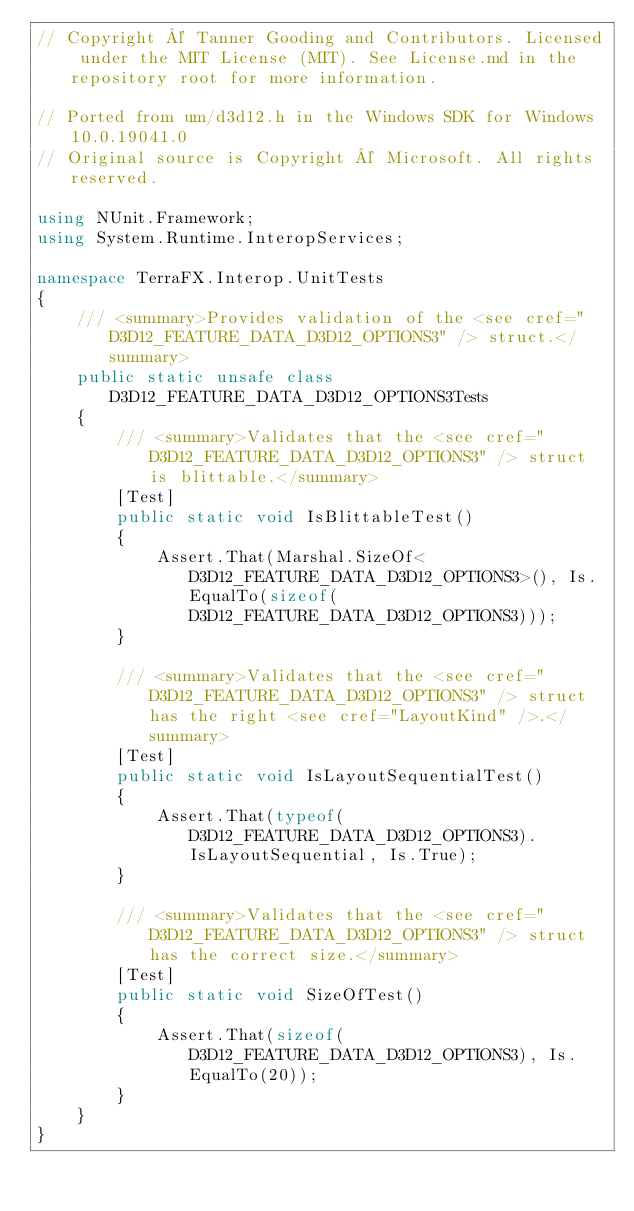<code> <loc_0><loc_0><loc_500><loc_500><_C#_>// Copyright © Tanner Gooding and Contributors. Licensed under the MIT License (MIT). See License.md in the repository root for more information.

// Ported from um/d3d12.h in the Windows SDK for Windows 10.0.19041.0
// Original source is Copyright © Microsoft. All rights reserved.

using NUnit.Framework;
using System.Runtime.InteropServices;

namespace TerraFX.Interop.UnitTests
{
    /// <summary>Provides validation of the <see cref="D3D12_FEATURE_DATA_D3D12_OPTIONS3" /> struct.</summary>
    public static unsafe class D3D12_FEATURE_DATA_D3D12_OPTIONS3Tests
    {
        /// <summary>Validates that the <see cref="D3D12_FEATURE_DATA_D3D12_OPTIONS3" /> struct is blittable.</summary>
        [Test]
        public static void IsBlittableTest()
        {
            Assert.That(Marshal.SizeOf<D3D12_FEATURE_DATA_D3D12_OPTIONS3>(), Is.EqualTo(sizeof(D3D12_FEATURE_DATA_D3D12_OPTIONS3)));
        }

        /// <summary>Validates that the <see cref="D3D12_FEATURE_DATA_D3D12_OPTIONS3" /> struct has the right <see cref="LayoutKind" />.</summary>
        [Test]
        public static void IsLayoutSequentialTest()
        {
            Assert.That(typeof(D3D12_FEATURE_DATA_D3D12_OPTIONS3).IsLayoutSequential, Is.True);
        }

        /// <summary>Validates that the <see cref="D3D12_FEATURE_DATA_D3D12_OPTIONS3" /> struct has the correct size.</summary>
        [Test]
        public static void SizeOfTest()
        {
            Assert.That(sizeof(D3D12_FEATURE_DATA_D3D12_OPTIONS3), Is.EqualTo(20));
        }
    }
}
</code> 